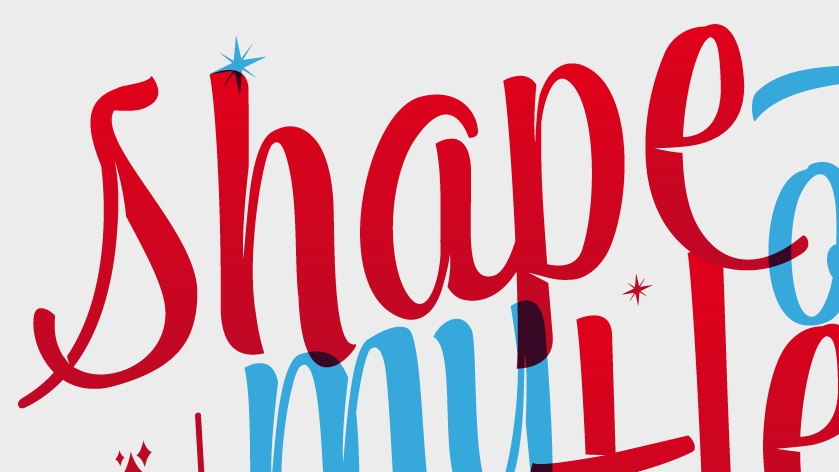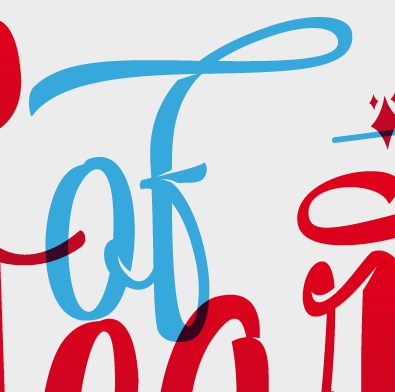What words can you see in these images in sequence, separated by a semicolon? shape; of 